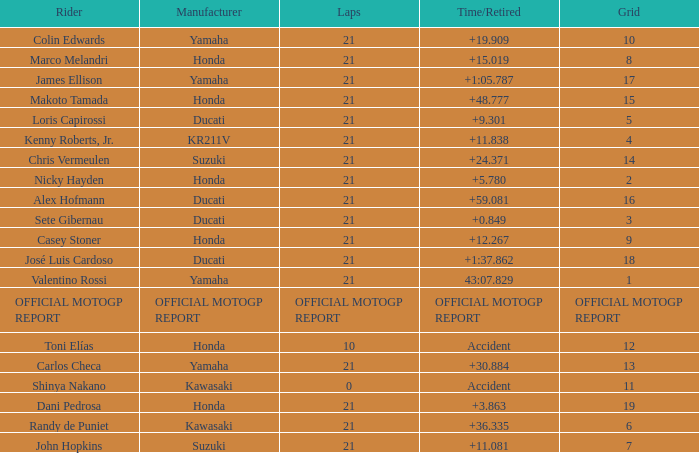What was the amount of laps for the vehicle manufactured by honda with a grid of 9? 21.0. 